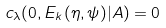Convert formula to latex. <formula><loc_0><loc_0><loc_500><loc_500>c _ { \lambda } ( 0 , E _ { k } ( \eta , \psi ) | A ) & = 0</formula> 